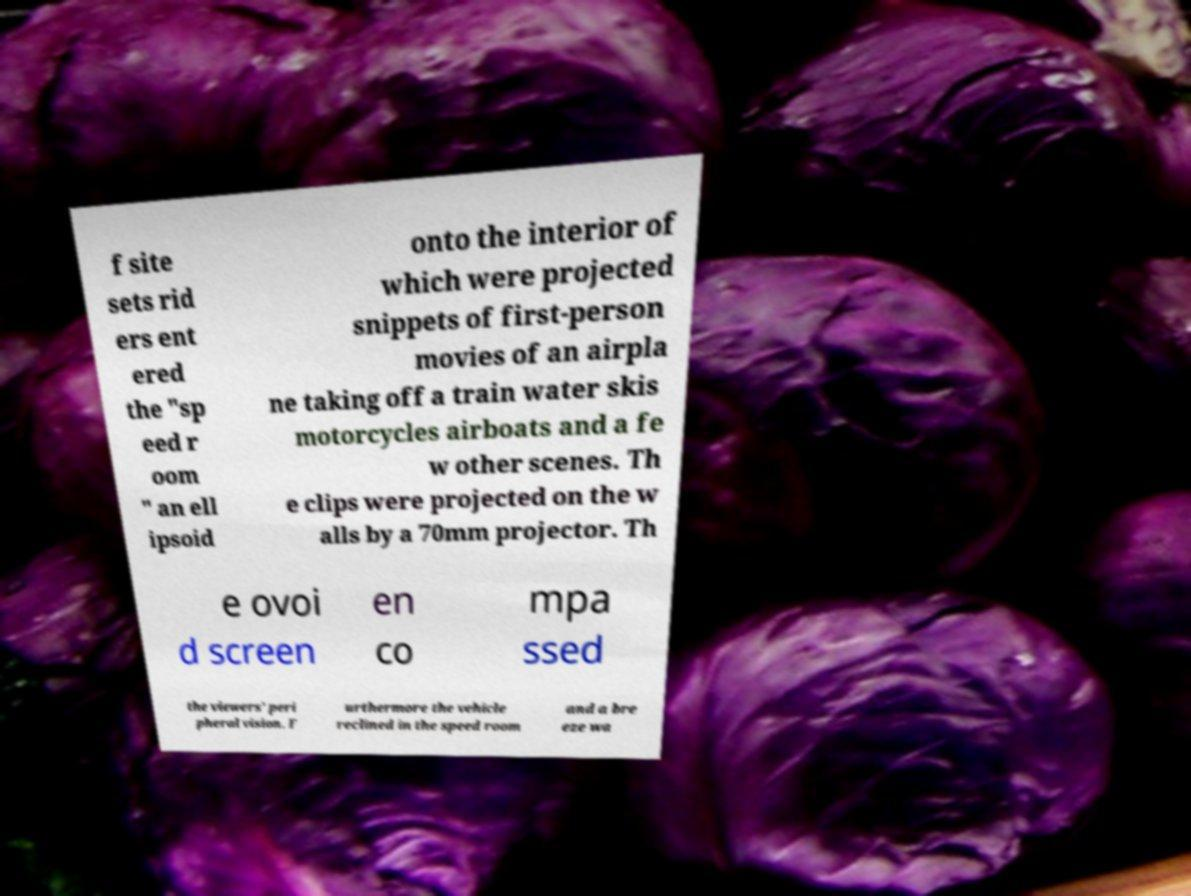Could you assist in decoding the text presented in this image and type it out clearly? f site sets rid ers ent ered the "sp eed r oom " an ell ipsoid onto the interior of which were projected snippets of first-person movies of an airpla ne taking off a train water skis motorcycles airboats and a fe w other scenes. Th e clips were projected on the w alls by a 70mm projector. Th e ovoi d screen en co mpa ssed the viewers' peri pheral vision. F urthermore the vehicle reclined in the speed room and a bre eze wa 